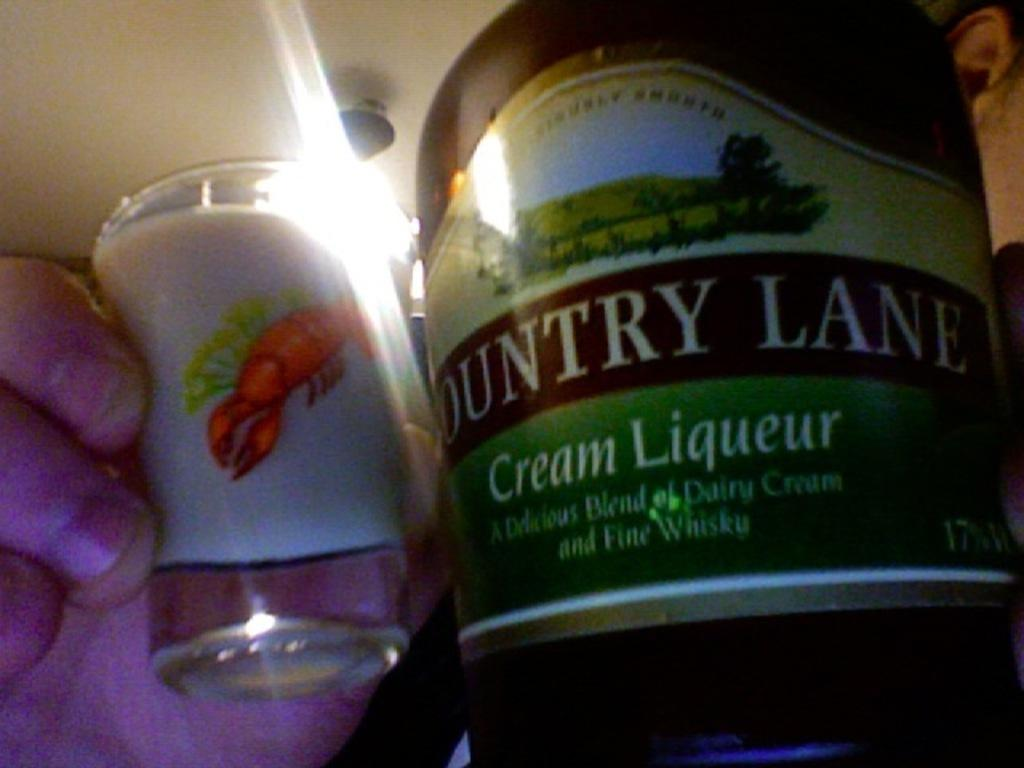<image>
Present a compact description of the photo's key features. A bottle of Country lane Cream Liqueur has bene poured into a lobster shot glass 